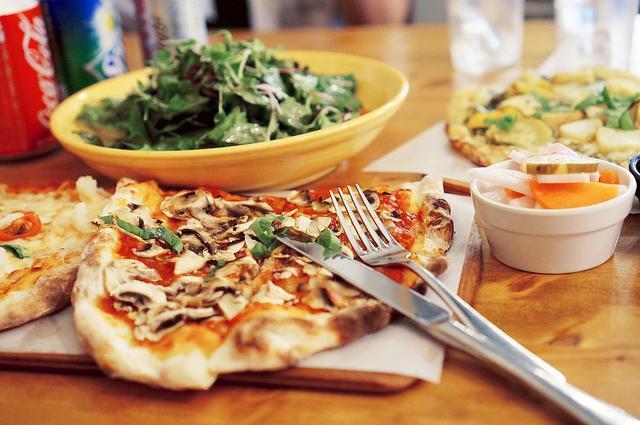How many cups are there?
Give a very brief answer. 2. How many pizzas are there?
Give a very brief answer. 2. How many bowls are there?
Give a very brief answer. 2. How many people are wearing an orange tee shirt?
Give a very brief answer. 0. 